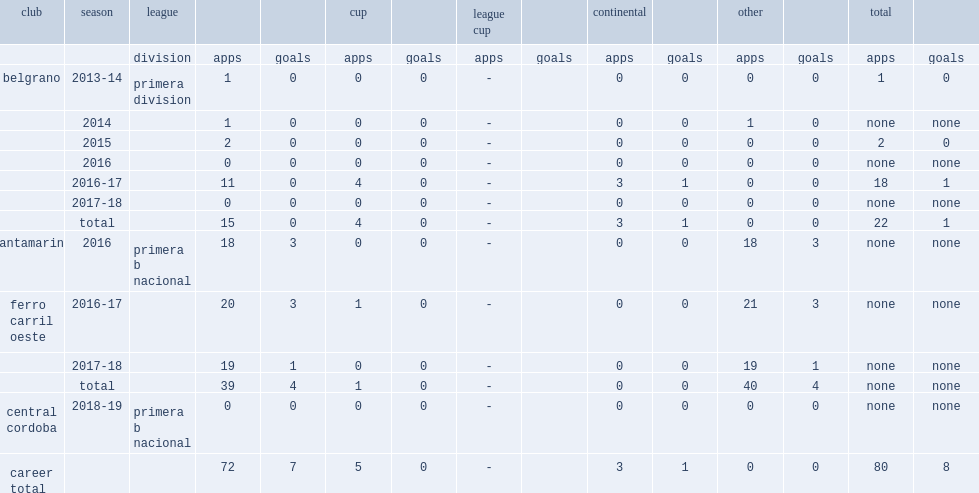Help me parse the entirety of this table. {'header': ['club', 'season', 'league', '', '', 'cup', '', 'league cup', '', 'continental', '', 'other', '', 'total', ''], 'rows': [['', '', 'division', 'apps', 'goals', 'apps', 'goals', 'apps', 'goals', 'apps', 'goals', 'apps', 'goals', 'apps', 'goals'], ['belgrano', '2013-14', 'primera division', '1', '0', '0', '0', '-', '', '0', '0', '0', '0', '1', '0'], ['', '2014', '', '1', '0', '0', '0', '-', '', '0', '0', '1', '0', 'none', 'none'], ['', '2015', '', '2', '0', '0', '0', '-', '', '0', '0', '0', '0', '2', '0'], ['', '2016', '', '0', '0', '0', '0', '-', '', '0', '0', '0', '0', 'none', 'none'], ['', '2016-17', '', '11', '0', '4', '0', '-', '', '3', '1', '0', '0', '18', '1'], ['', '2017-18', '', '0', '0', '0', '0', '-', '', '0', '0', '0', '0', 'none', 'none'], ['', 'total', '', '15', '0', '4', '0', '-', '', '3', '1', '0', '0', '22', '1'], ['santamarina', '2016', 'primera b nacional', '18', '3', '0', '0', '-', '', '0', '0', '18', '3', 'none', 'none'], ['ferro carril oeste', '2016-17', '', '20', '3', '1', '0', '-', '', '0', '0', '21', '3', 'none', 'none'], ['', '2017-18', '', '19', '1', '0', '0', '-', '', '0', '0', '19', '1', 'none', 'none'], ['', 'total', '', '39', '4', '1', '0', '-', '', '0', '0', '40', '4', 'none', 'none'], ['central cordoba', '2018-19', 'primera b nacional', '0', '0', '0', '0', '-', '', '0', '0', '0', '0', 'none', 'none'], ['career total', '', '', '72', '7', '5', '0', '-', '', '3', '1', '0', '0', '80', '8']]} Which club did lujan begin with primera division in 2014? Belgrano. 